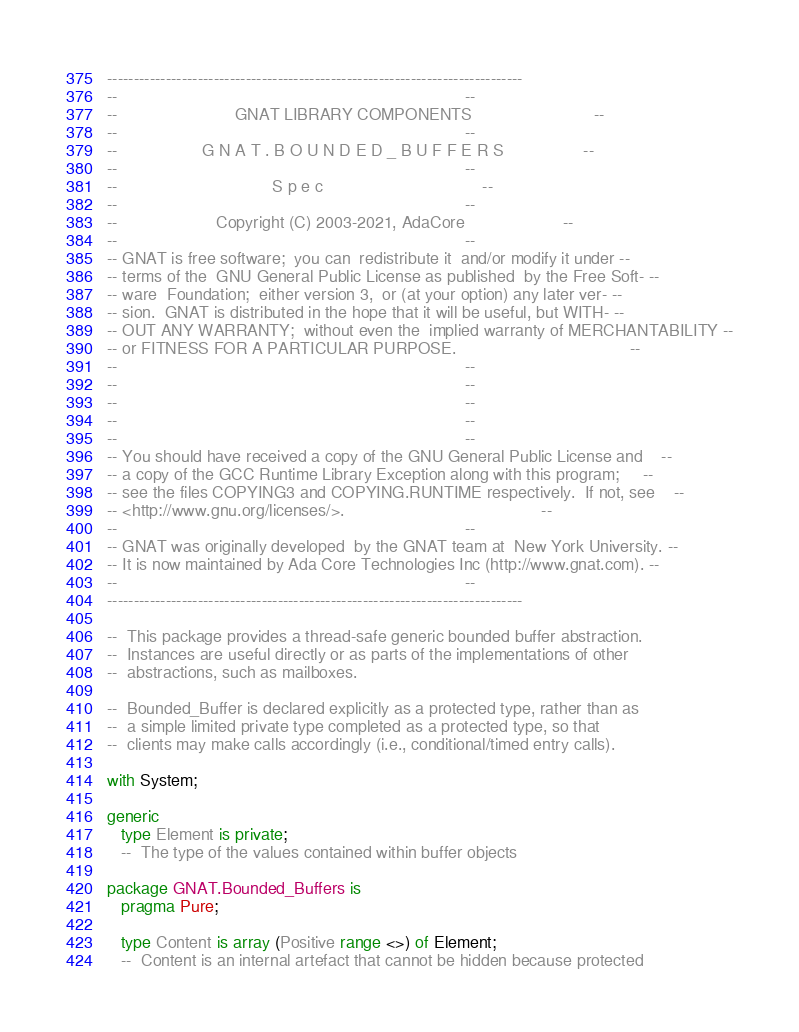<code> <loc_0><loc_0><loc_500><loc_500><_Ada_>------------------------------------------------------------------------------
--                                                                          --
--                         GNAT LIBRARY COMPONENTS                          --
--                                                                          --
--                  G N A T . B O U N D E D _ B U F F E R S                 --
--                                                                          --
--                                 S p e c                                  --
--                                                                          --
--                     Copyright (C) 2003-2021, AdaCore                     --
--                                                                          --
-- GNAT is free software;  you can  redistribute it  and/or modify it under --
-- terms of the  GNU General Public License as published  by the Free Soft- --
-- ware  Foundation;  either version 3,  or (at your option) any later ver- --
-- sion.  GNAT is distributed in the hope that it will be useful, but WITH- --
-- OUT ANY WARRANTY;  without even the  implied warranty of MERCHANTABILITY --
-- or FITNESS FOR A PARTICULAR PURPOSE.                                     --
--                                                                          --
--                                                                          --
--                                                                          --
--                                                                          --
--                                                                          --
-- You should have received a copy of the GNU General Public License and    --
-- a copy of the GCC Runtime Library Exception along with this program;     --
-- see the files COPYING3 and COPYING.RUNTIME respectively.  If not, see    --
-- <http://www.gnu.org/licenses/>.                                          --
--                                                                          --
-- GNAT was originally developed  by the GNAT team at  New York University. --
-- It is now maintained by Ada Core Technologies Inc (http://www.gnat.com). --
--                                                                          --
------------------------------------------------------------------------------

--  This package provides a thread-safe generic bounded buffer abstraction.
--  Instances are useful directly or as parts of the implementations of other
--  abstractions, such as mailboxes.

--  Bounded_Buffer is declared explicitly as a protected type, rather than as
--  a simple limited private type completed as a protected type, so that
--  clients may make calls accordingly (i.e., conditional/timed entry calls).

with System;

generic
   type Element is private;
   --  The type of the values contained within buffer objects

package GNAT.Bounded_Buffers is
   pragma Pure;

   type Content is array (Positive range <>) of Element;
   --  Content is an internal artefact that cannot be hidden because protected</code> 